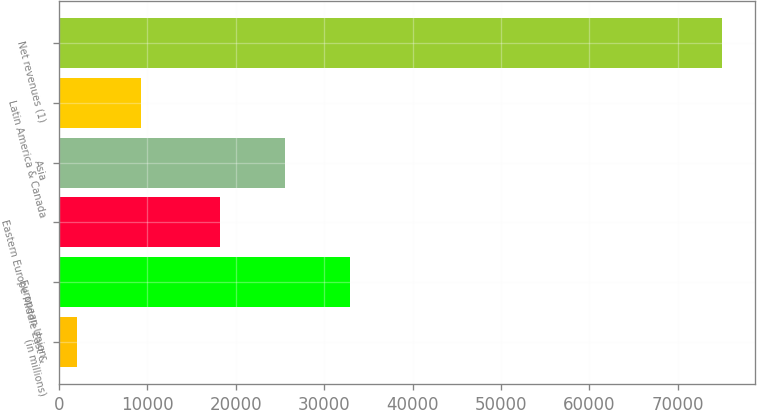<chart> <loc_0><loc_0><loc_500><loc_500><bar_chart><fcel>(in millions)<fcel>European Union<fcel>Eastern Europe Middle East &<fcel>Asia<fcel>Latin America & Canada<fcel>Net revenues (1)<nl><fcel>2016<fcel>32873.4<fcel>18286<fcel>25579.7<fcel>9309.7<fcel>74953<nl></chart> 